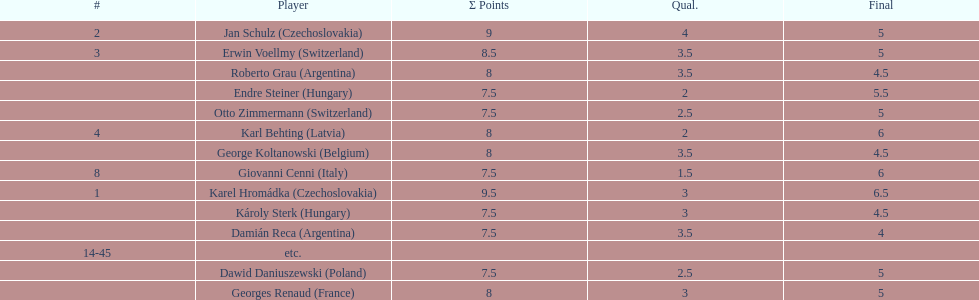The most points were scored by which player? Karel Hromádka. 